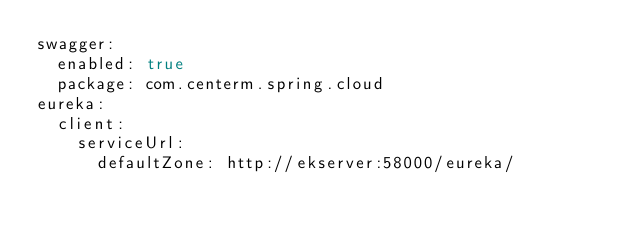<code> <loc_0><loc_0><loc_500><loc_500><_YAML_>swagger:
  enabled: true
  package: com.centerm.spring.cloud
eureka:
  client:
    serviceUrl:
      defaultZone: http://ekserver:58000/eureka/</code> 